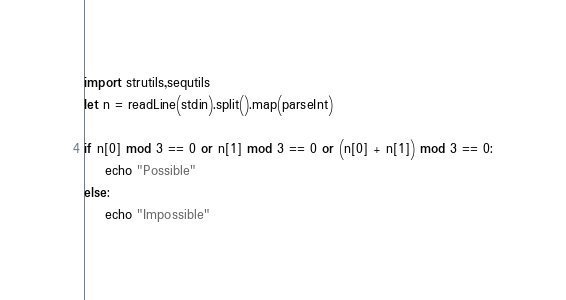Convert code to text. <code><loc_0><loc_0><loc_500><loc_500><_Nim_>import strutils,sequtils
let n = readLine(stdin).split().map(parseInt)

if n[0] mod 3 == 0 or n[1] mod 3 == 0 or (n[0] + n[1]) mod 3 == 0:
    echo "Possible"
else:
    echo "Impossible"</code> 